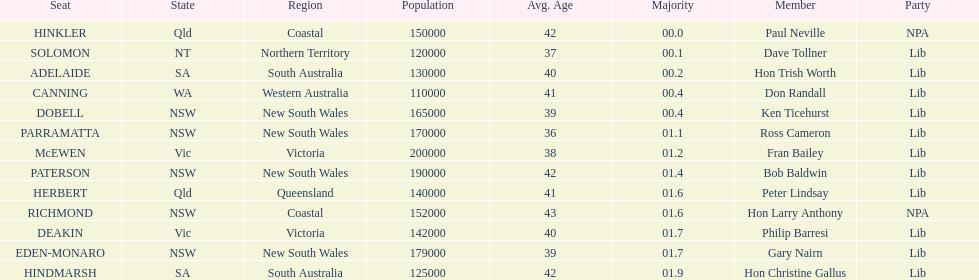How many states were represented in the seats? 6. 